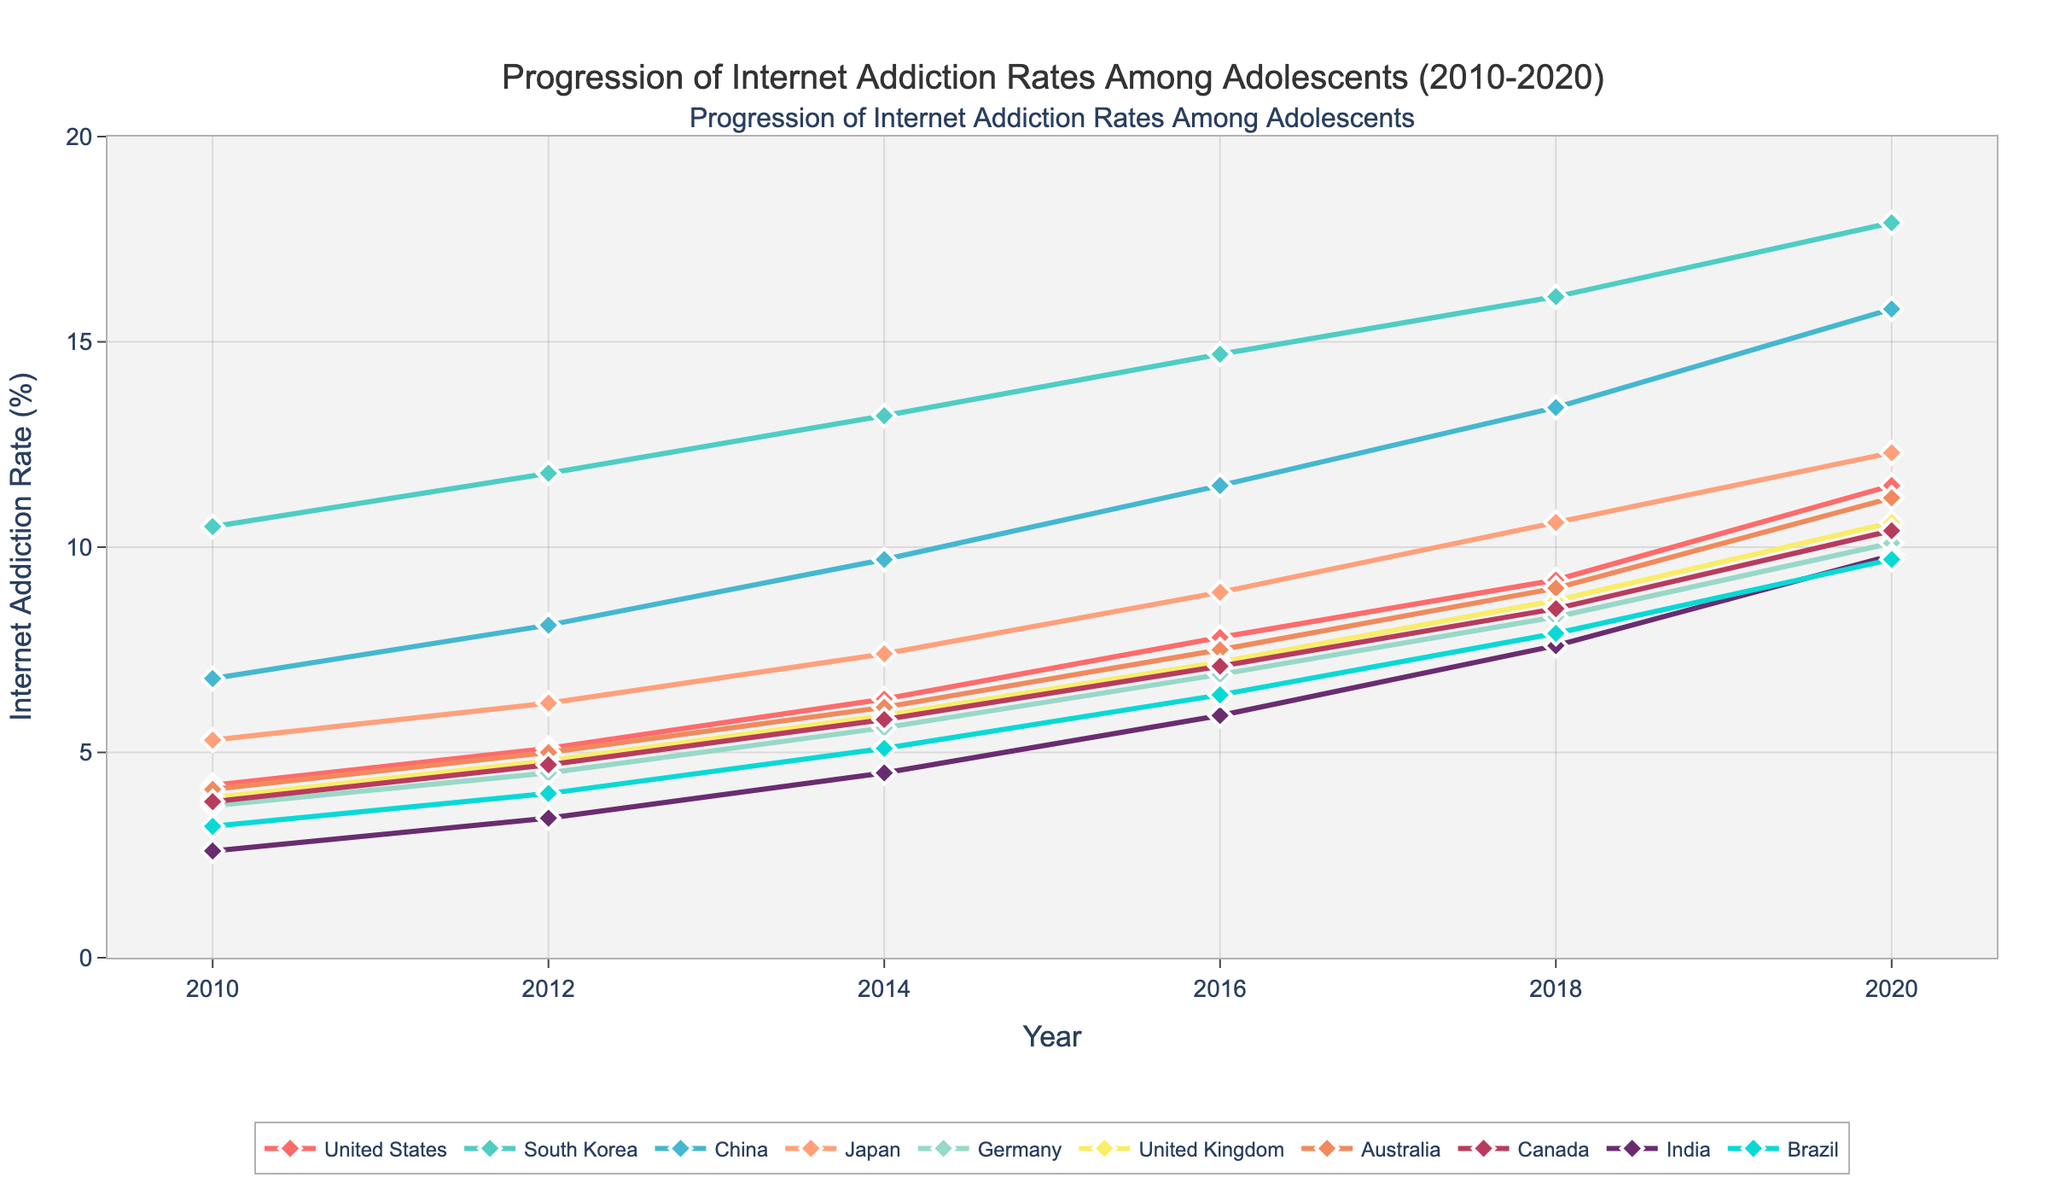Which country had the highest internet addiction rate in 2020? According to the data, we need to look at the rate for each country in 2020. South Korea has the highest rate at 17.9%.
Answer: South Korea How did the internet addiction rate for China change from 2010 to 2020? Check China's rates for 2010 (6.8%) and 2020 (15.8%). Calculate the difference: 15.8% - 6.8% = 9%.
Answer: It increased by 9% Which three countries had the lowest internet addiction rates in 2010? Identify the rates for all countries in 2010. The three countries with the lowest rates are India (2.6%), Brazil (3.2%), and Canada (3.8%).
Answer: India, Brazil, Canada What is the average internet addiction rate in the United States across all years shown? Add the rates for 2010 (4.2%), 2012 (5.1%), 2014 (6.3%), 2016 (7.8%), 2018 (9.2%), and 2020 (11.5%), then divide by 6: (4.2 + 5.1 + 6.3 + 7.8 + 9.2 + 11.5) / 6 ≈ 7.35%.
Answer: 7.35% Which country showed the greatest rate increase between 2010 and 2020? Calculate the rate increase for each country from 2010 to 2020. South Korea showed the greatest increase: 17.9% - 10.5% = 7.4%.
Answer: South Korea By how much did the internet addiction rate for Japan change between 2014 and 2020? Look at the rates for Japan in 2014 (7.4%) and 2020 (12.3%). The change is 12.3% - 7.4% = 4.9%.
Answer: 4.9% Which country had a lower internet addiction rate in 2016, Germany or Australia? Compare the rates for Germany (6.9%) and Australia (7.5%) in 2016. Germany's rate is lower.
Answer: Germany What color represents the United Kingdom’s line in the chart? Identify the color associated with the United Kingdom in the legend or the line corresponding to its data points. The color is a specific shade (provide example based on the chart).
Answer: Color specific to the chart (e.g., blue) What is the median internet addiction rate for India over the years shown? Arrange India's rates in ascending order: 2.6, 3.4, 4.5, 5.9, 7.6, 9.8. The median is the average of the middle two values: (4.5 + 5.9) / 2 = 5.2%.
Answer: 5.2% Which country had the second-highest internet addiction rate in 2018? Check the rates for 2018. China has the highest rate, followed by South Korea with 16.1%.
Answer: South Korea 